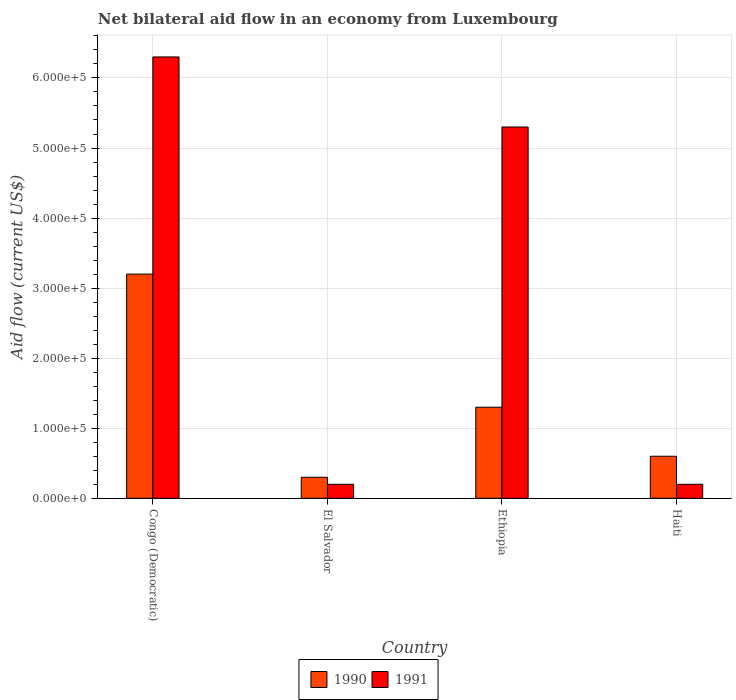How many different coloured bars are there?
Ensure brevity in your answer.  2. How many bars are there on the 2nd tick from the left?
Give a very brief answer. 2. What is the label of the 3rd group of bars from the left?
Keep it short and to the point. Ethiopia. In how many cases, is the number of bars for a given country not equal to the number of legend labels?
Your answer should be compact. 0. What is the net bilateral aid flow in 1990 in El Salvador?
Offer a terse response. 3.00e+04. Across all countries, what is the minimum net bilateral aid flow in 1991?
Offer a very short reply. 2.00e+04. In which country was the net bilateral aid flow in 1991 maximum?
Provide a short and direct response. Congo (Democratic). In which country was the net bilateral aid flow in 1990 minimum?
Make the answer very short. El Salvador. What is the total net bilateral aid flow in 1990 in the graph?
Provide a short and direct response. 5.40e+05. What is the difference between the net bilateral aid flow in 1990 in Congo (Democratic) and that in Ethiopia?
Keep it short and to the point. 1.90e+05. What is the difference between the net bilateral aid flow in 1990 in Ethiopia and the net bilateral aid flow in 1991 in Congo (Democratic)?
Your response must be concise. -5.00e+05. What is the average net bilateral aid flow in 1991 per country?
Your answer should be very brief. 3.00e+05. In how many countries, is the net bilateral aid flow in 1991 greater than 100000 US$?
Provide a succinct answer. 2. What is the ratio of the net bilateral aid flow in 1990 in El Salvador to that in Ethiopia?
Offer a terse response. 0.23. Is the net bilateral aid flow in 1990 in El Salvador less than that in Ethiopia?
Provide a succinct answer. Yes. What is the difference between the highest and the lowest net bilateral aid flow in 1990?
Provide a short and direct response. 2.90e+05. Is the sum of the net bilateral aid flow in 1991 in Congo (Democratic) and El Salvador greater than the maximum net bilateral aid flow in 1990 across all countries?
Offer a very short reply. Yes. How many bars are there?
Offer a very short reply. 8. Does the graph contain any zero values?
Provide a short and direct response. No. Does the graph contain grids?
Your response must be concise. Yes. How are the legend labels stacked?
Ensure brevity in your answer.  Horizontal. What is the title of the graph?
Your response must be concise. Net bilateral aid flow in an economy from Luxembourg. Does "1991" appear as one of the legend labels in the graph?
Offer a terse response. Yes. What is the Aid flow (current US$) of 1991 in Congo (Democratic)?
Ensure brevity in your answer.  6.30e+05. What is the Aid flow (current US$) in 1990 in El Salvador?
Your answer should be very brief. 3.00e+04. What is the Aid flow (current US$) in 1990 in Ethiopia?
Offer a very short reply. 1.30e+05. What is the Aid flow (current US$) of 1991 in Ethiopia?
Provide a succinct answer. 5.30e+05. What is the Aid flow (current US$) in 1990 in Haiti?
Provide a succinct answer. 6.00e+04. What is the Aid flow (current US$) in 1991 in Haiti?
Your response must be concise. 2.00e+04. Across all countries, what is the maximum Aid flow (current US$) of 1991?
Make the answer very short. 6.30e+05. Across all countries, what is the minimum Aid flow (current US$) in 1991?
Offer a terse response. 2.00e+04. What is the total Aid flow (current US$) in 1990 in the graph?
Your response must be concise. 5.40e+05. What is the total Aid flow (current US$) of 1991 in the graph?
Give a very brief answer. 1.20e+06. What is the difference between the Aid flow (current US$) in 1991 in Congo (Democratic) and that in El Salvador?
Give a very brief answer. 6.10e+05. What is the difference between the Aid flow (current US$) in 1990 in Congo (Democratic) and that in Ethiopia?
Offer a terse response. 1.90e+05. What is the difference between the Aid flow (current US$) of 1991 in El Salvador and that in Ethiopia?
Ensure brevity in your answer.  -5.10e+05. What is the difference between the Aid flow (current US$) of 1991 in El Salvador and that in Haiti?
Ensure brevity in your answer.  0. What is the difference between the Aid flow (current US$) of 1990 in Ethiopia and that in Haiti?
Your answer should be compact. 7.00e+04. What is the difference between the Aid flow (current US$) of 1991 in Ethiopia and that in Haiti?
Provide a succinct answer. 5.10e+05. What is the difference between the Aid flow (current US$) of 1990 in Congo (Democratic) and the Aid flow (current US$) of 1991 in El Salvador?
Ensure brevity in your answer.  3.00e+05. What is the difference between the Aid flow (current US$) of 1990 in El Salvador and the Aid flow (current US$) of 1991 in Ethiopia?
Make the answer very short. -5.00e+05. What is the difference between the Aid flow (current US$) of 1990 in El Salvador and the Aid flow (current US$) of 1991 in Haiti?
Give a very brief answer. 10000. What is the difference between the Aid flow (current US$) of 1990 in Ethiopia and the Aid flow (current US$) of 1991 in Haiti?
Offer a very short reply. 1.10e+05. What is the average Aid flow (current US$) in 1990 per country?
Ensure brevity in your answer.  1.35e+05. What is the difference between the Aid flow (current US$) of 1990 and Aid flow (current US$) of 1991 in Congo (Democratic)?
Your response must be concise. -3.10e+05. What is the difference between the Aid flow (current US$) in 1990 and Aid flow (current US$) in 1991 in El Salvador?
Provide a succinct answer. 10000. What is the difference between the Aid flow (current US$) in 1990 and Aid flow (current US$) in 1991 in Ethiopia?
Your answer should be very brief. -4.00e+05. What is the difference between the Aid flow (current US$) of 1990 and Aid flow (current US$) of 1991 in Haiti?
Your answer should be compact. 4.00e+04. What is the ratio of the Aid flow (current US$) in 1990 in Congo (Democratic) to that in El Salvador?
Your response must be concise. 10.67. What is the ratio of the Aid flow (current US$) in 1991 in Congo (Democratic) to that in El Salvador?
Your answer should be compact. 31.5. What is the ratio of the Aid flow (current US$) in 1990 in Congo (Democratic) to that in Ethiopia?
Make the answer very short. 2.46. What is the ratio of the Aid flow (current US$) in 1991 in Congo (Democratic) to that in Ethiopia?
Keep it short and to the point. 1.19. What is the ratio of the Aid flow (current US$) of 1990 in Congo (Democratic) to that in Haiti?
Offer a very short reply. 5.33. What is the ratio of the Aid flow (current US$) of 1991 in Congo (Democratic) to that in Haiti?
Ensure brevity in your answer.  31.5. What is the ratio of the Aid flow (current US$) of 1990 in El Salvador to that in Ethiopia?
Your answer should be compact. 0.23. What is the ratio of the Aid flow (current US$) of 1991 in El Salvador to that in Ethiopia?
Keep it short and to the point. 0.04. What is the ratio of the Aid flow (current US$) of 1990 in El Salvador to that in Haiti?
Your answer should be compact. 0.5. What is the ratio of the Aid flow (current US$) in 1991 in El Salvador to that in Haiti?
Your answer should be very brief. 1. What is the ratio of the Aid flow (current US$) in 1990 in Ethiopia to that in Haiti?
Ensure brevity in your answer.  2.17. What is the difference between the highest and the second highest Aid flow (current US$) of 1990?
Your answer should be very brief. 1.90e+05. What is the difference between the highest and the second highest Aid flow (current US$) in 1991?
Make the answer very short. 1.00e+05. What is the difference between the highest and the lowest Aid flow (current US$) of 1990?
Provide a succinct answer. 2.90e+05. 